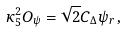Convert formula to latex. <formula><loc_0><loc_0><loc_500><loc_500>\kappa _ { 5 } ^ { 2 } O _ { \psi } = \sqrt { 2 } C _ { \Delta } \psi _ { r } \, ,</formula> 